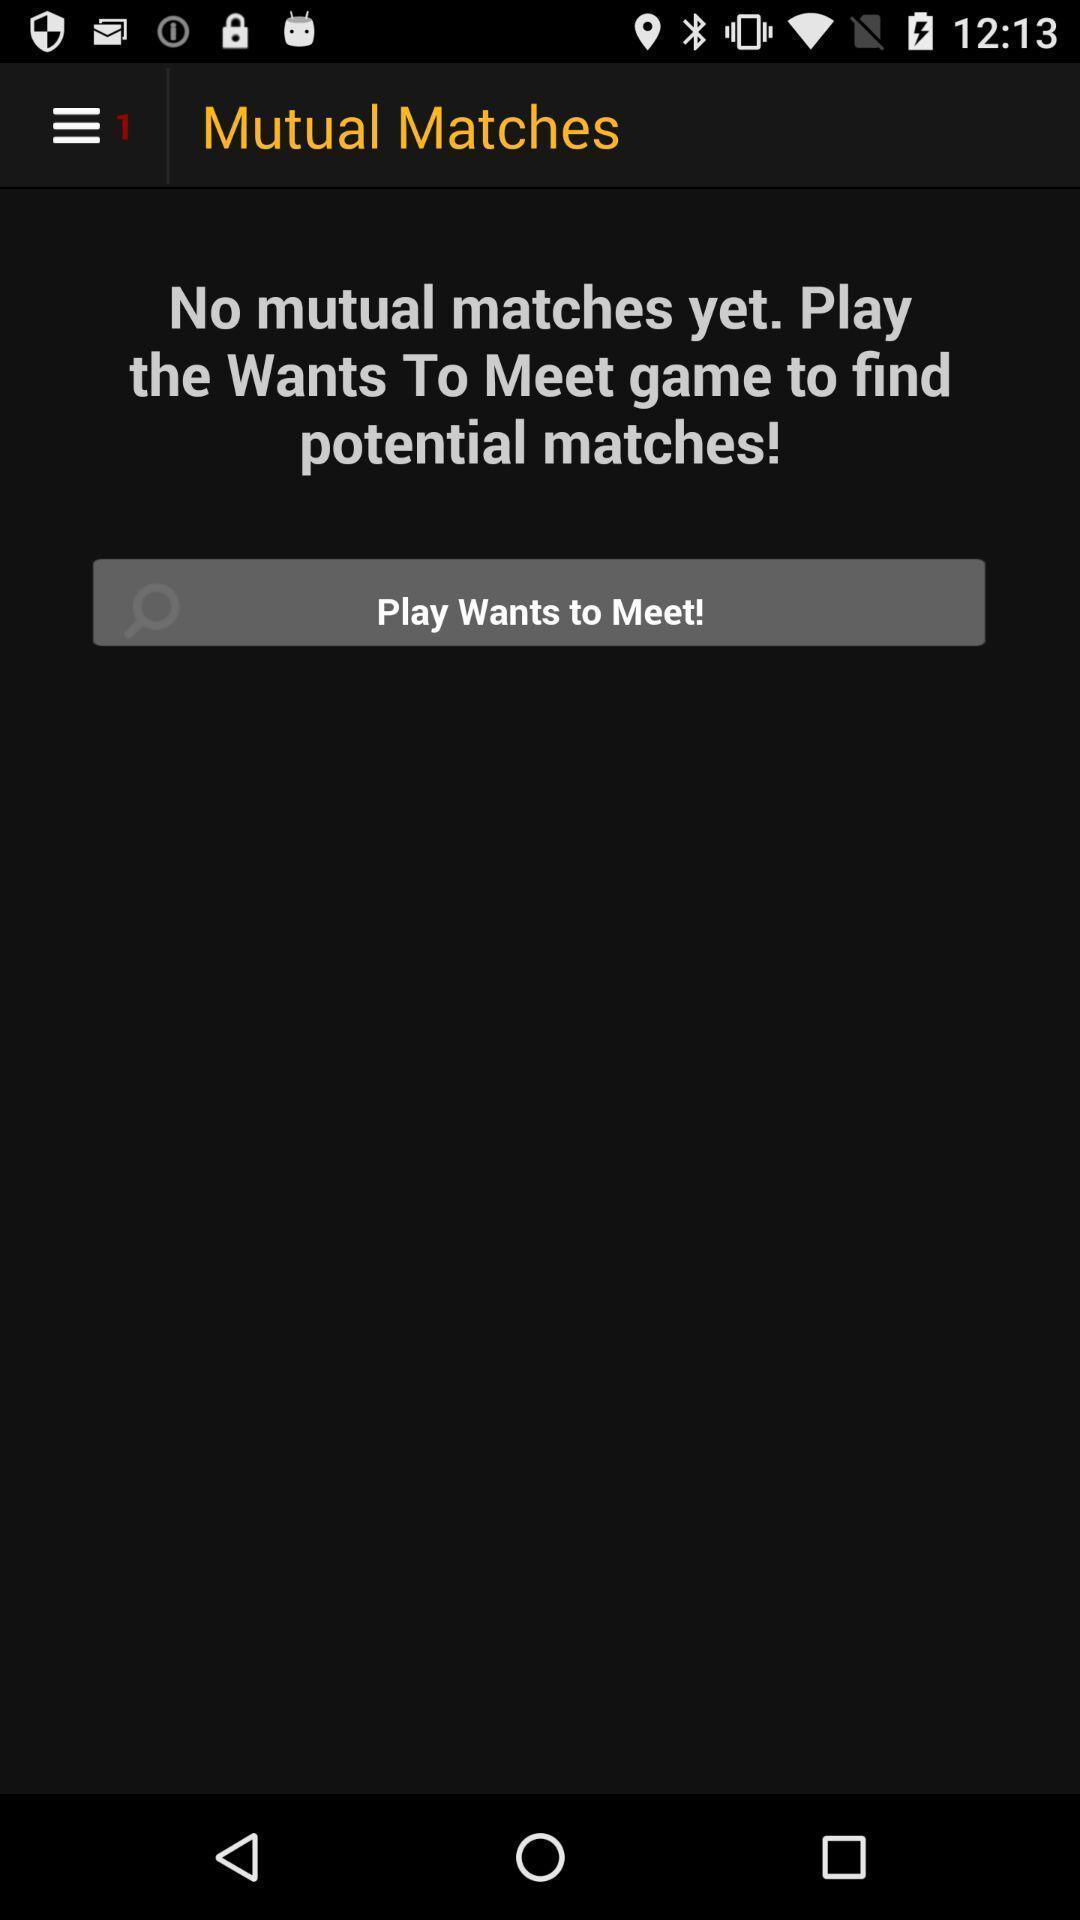What is the overall content of this screenshot? Page shows a message about matches in the dating app. 